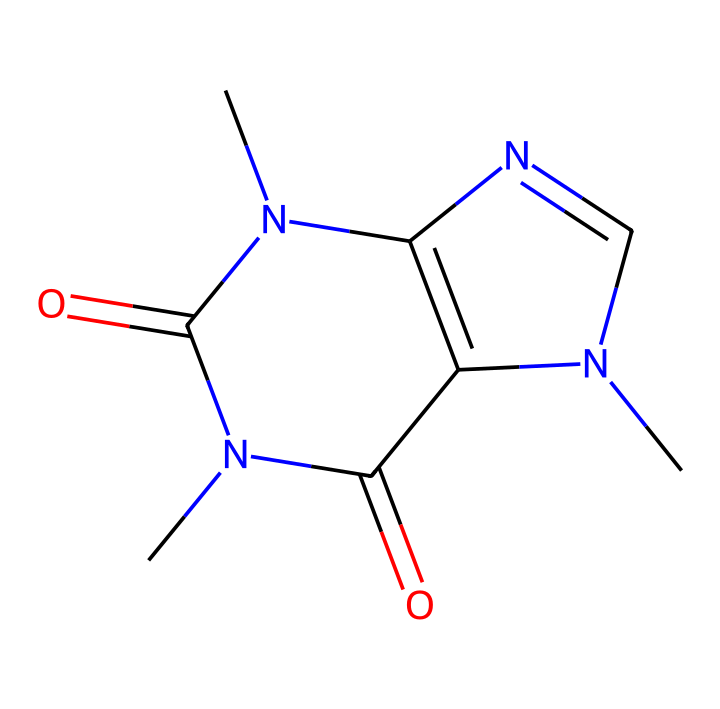What is the molecular formula of caffeine? The SMILES representation provided can be analyzed to count the atoms of each element. The representation contains three carbon (C) atoms, four nitrogen (N) atoms, and two oxygen (O) atoms. Thus the molecular formula is calculated as C8H10N4O2.
Answer: C8H10N4O2 How many rings are present in the structure of caffeine? By examining the SMILES structure, there are two interconnected rings formed from the cyclic portions of the molecule. Each cycle is formed by atoms connected in a loop.
Answer: 2 What is the primary functional group present in caffeine? The structure shows carbonyl (C=O) groups, which are characteristic of amides in the context of this molecule. The counts of functional groups indicate that there are two carbonyl groups.
Answer: carbonyl What is the total number of nitrogen atoms in caffeine? The SMILES structure contains four nitrogen atoms (N). By counting each instance of nitrogen directly from the representation, we confirm this total.
Answer: 4 What type of stimulant effects does caffeine typically have on neural activity? Caffeine primarily acts as an antagonist of adenosine receptors, leading to increased alertness and reduced perception of fatigue. This is because it blocks the calming effects of adenosine, thus stimulating neural activity.
Answer: stimulant How does caffeine affect the central nervous system? Caffeine increases the release of neurotransmitters like dopamine and norepinephrine, which enhance excitation in the brain. This is a result of blocking adenosine receptors that typically promote relaxation.
Answer: excitation 